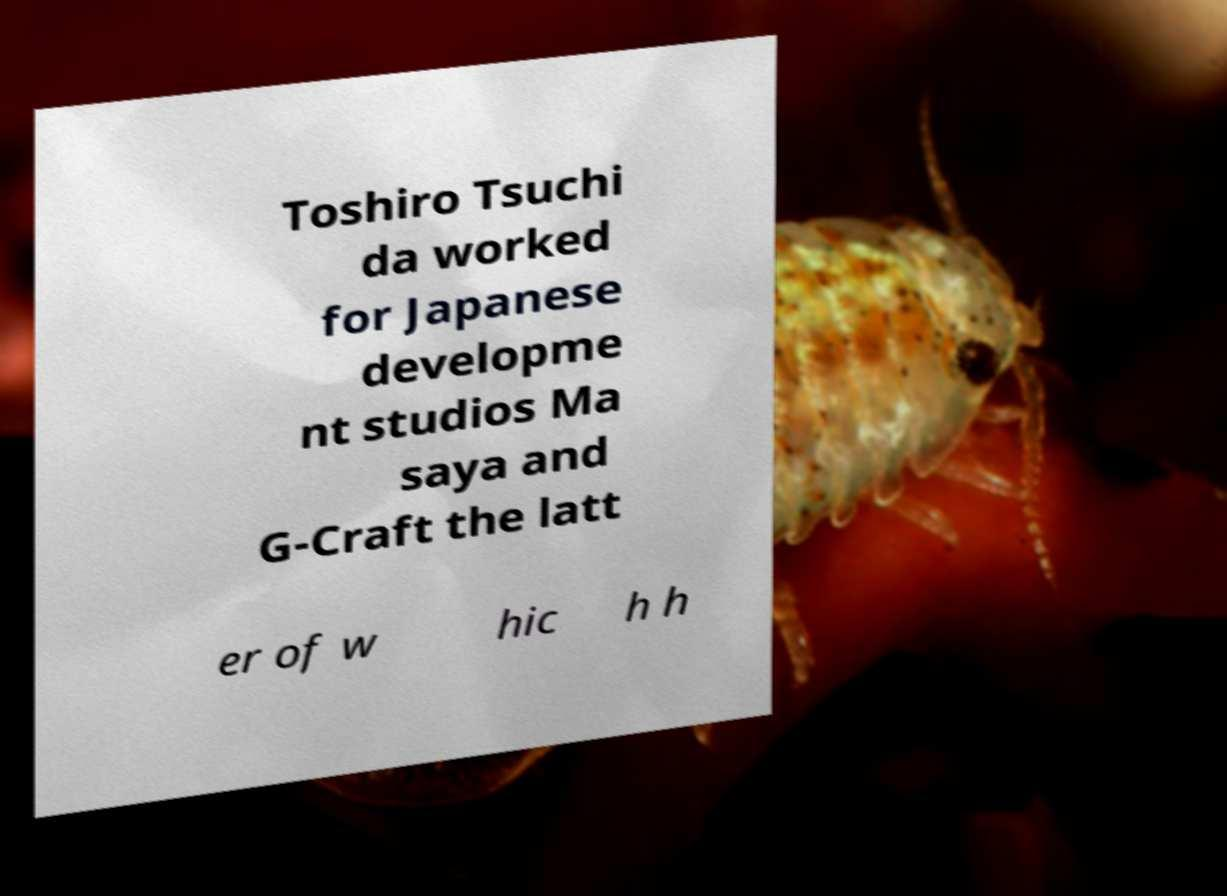What messages or text are displayed in this image? I need them in a readable, typed format. Toshiro Tsuchi da worked for Japanese developme nt studios Ma saya and G-Craft the latt er of w hic h h 